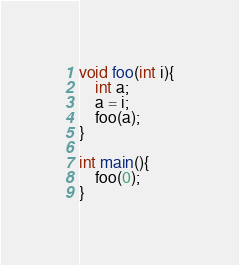<code> <loc_0><loc_0><loc_500><loc_500><_Cuda_>void foo(int i){
	int a;
	a = i;
	foo(a);
}

int main(){
	foo(0);
}
</code> 